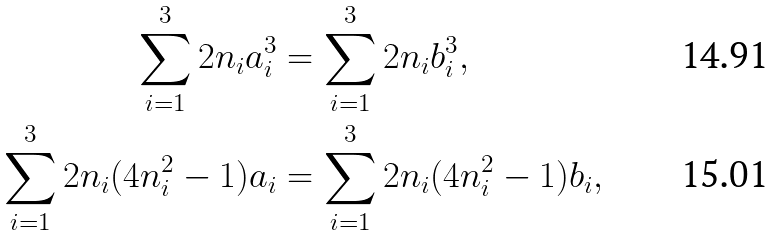Convert formula to latex. <formula><loc_0><loc_0><loc_500><loc_500>\sum _ { i = 1 } ^ { 3 } 2 n _ { i } a _ { i } ^ { 3 } & = \sum _ { i = 1 } ^ { 3 } 2 n _ { i } b _ { i } ^ { 3 } , \\ \sum _ { i = 1 } ^ { 3 } 2 n _ { i } ( 4 n _ { i } ^ { 2 } - 1 ) a _ { i } & = \sum _ { i = 1 } ^ { 3 } 2 n _ { i } ( 4 n _ { i } ^ { 2 } - 1 ) b _ { i } ,</formula> 